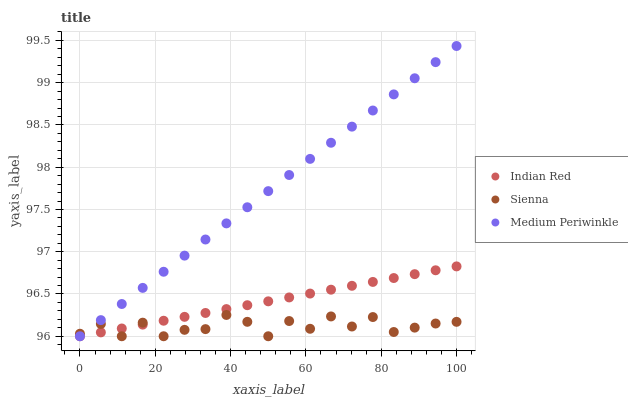Does Sienna have the minimum area under the curve?
Answer yes or no. Yes. Does Medium Periwinkle have the maximum area under the curve?
Answer yes or no. Yes. Does Indian Red have the minimum area under the curve?
Answer yes or no. No. Does Indian Red have the maximum area under the curve?
Answer yes or no. No. Is Medium Periwinkle the smoothest?
Answer yes or no. Yes. Is Sienna the roughest?
Answer yes or no. Yes. Is Indian Red the smoothest?
Answer yes or no. No. Is Indian Red the roughest?
Answer yes or no. No. Does Sienna have the lowest value?
Answer yes or no. Yes. Does Medium Periwinkle have the highest value?
Answer yes or no. Yes. Does Indian Red have the highest value?
Answer yes or no. No. Does Sienna intersect Indian Red?
Answer yes or no. Yes. Is Sienna less than Indian Red?
Answer yes or no. No. Is Sienna greater than Indian Red?
Answer yes or no. No. 